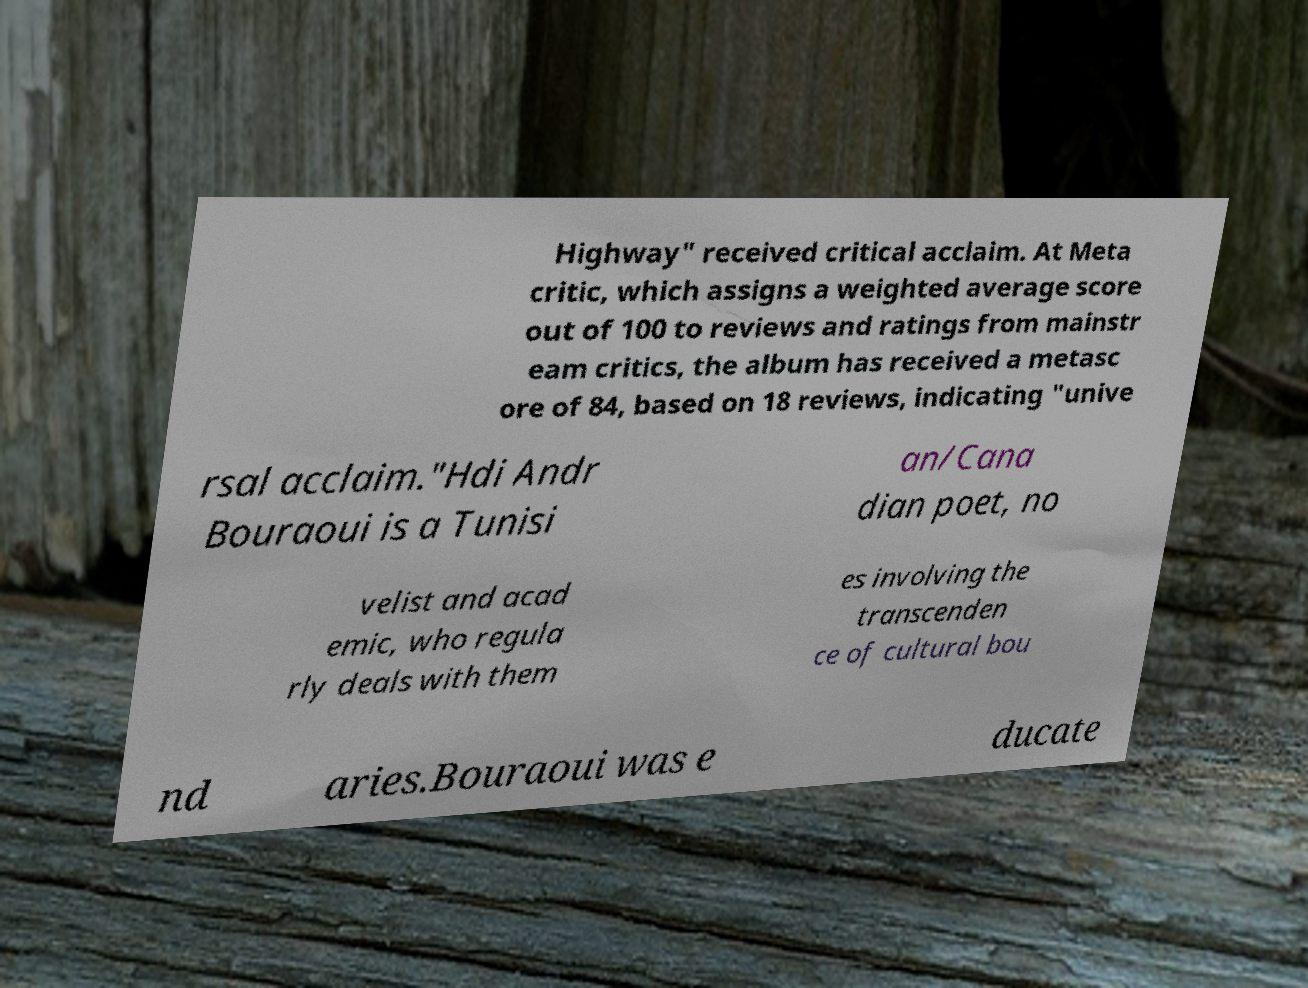Please identify and transcribe the text found in this image. Highway" received critical acclaim. At Meta critic, which assigns a weighted average score out of 100 to reviews and ratings from mainstr eam critics, the album has received a metasc ore of 84, based on 18 reviews, indicating "unive rsal acclaim."Hdi Andr Bouraoui is a Tunisi an/Cana dian poet, no velist and acad emic, who regula rly deals with them es involving the transcenden ce of cultural bou nd aries.Bouraoui was e ducate 